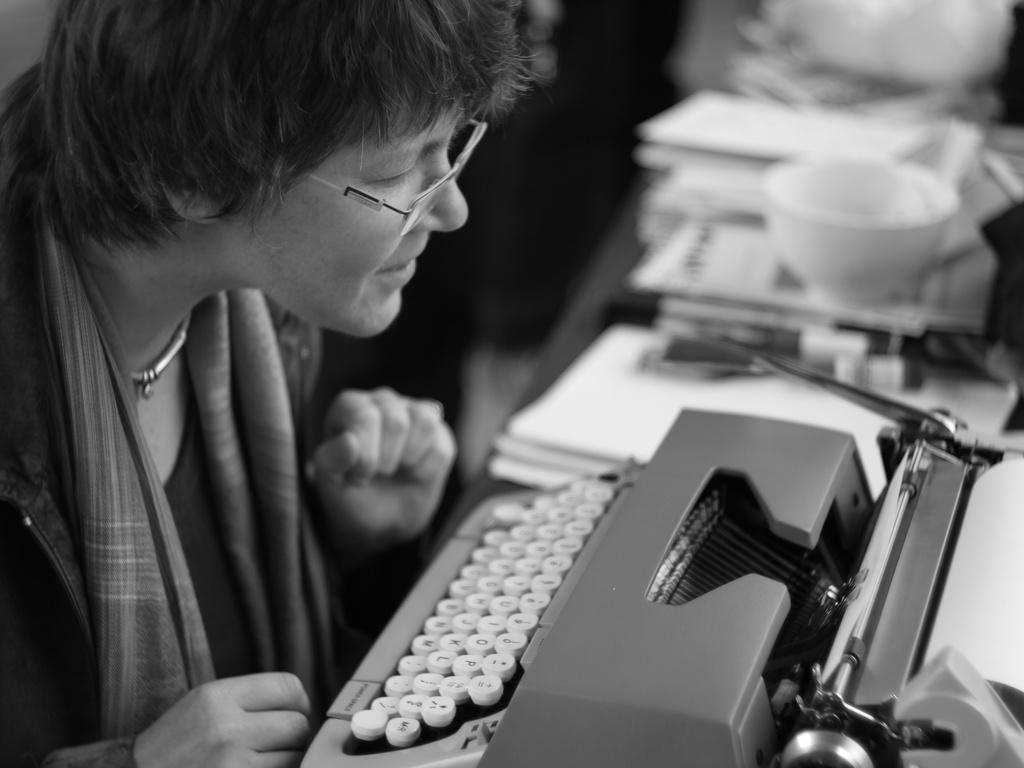What is the color scheme of the image? The image is black and white. Who is present in the image? There is a woman in the image. What object is in front of the woman? There is a typewriting machine in front of the woman. How is the background of the typewriting machine depicted? The background of the typewriting machine is blurred. What type of pollution can be seen in the image? There is no pollution present in the image. Can you describe the ocean in the image? There is no ocean present in the image. 